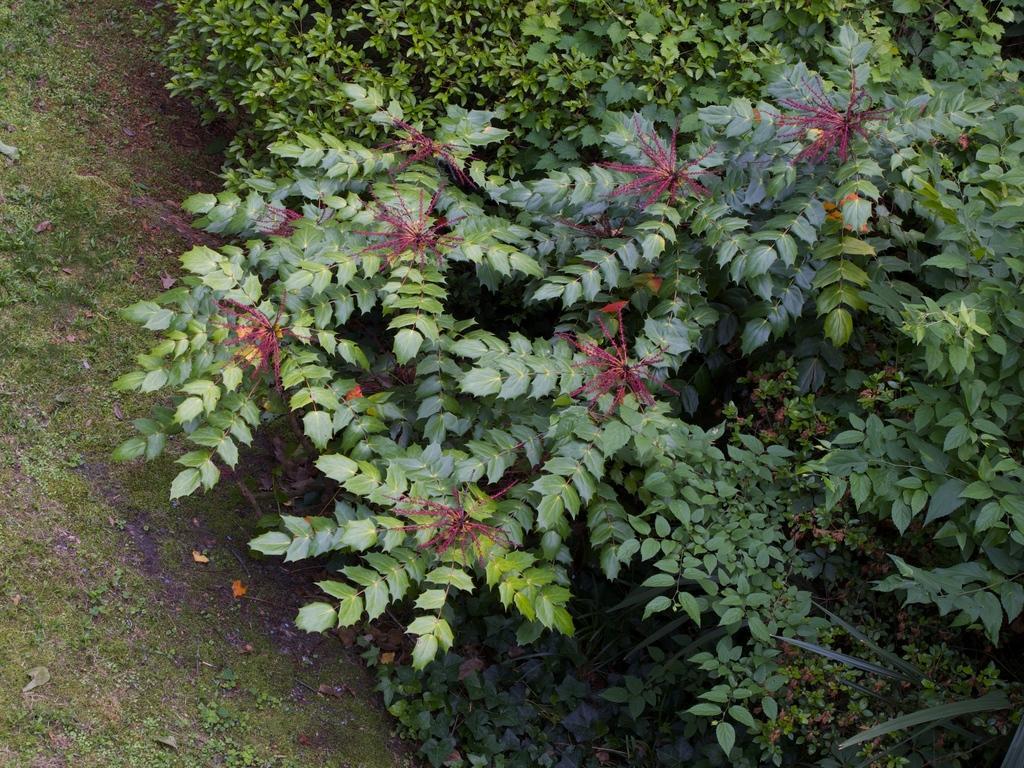Describe this image in one or two sentences. In this image I can see few green trees and the grass. 